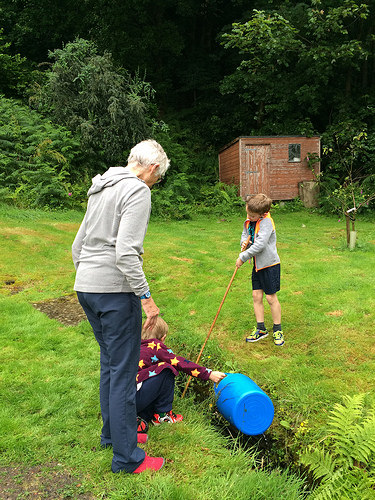<image>
Is the woman on the grace? Yes. Looking at the image, I can see the woman is positioned on top of the grace, with the grace providing support. Is the woman next to the shed? No. The woman is not positioned next to the shed. They are located in different areas of the scene. 